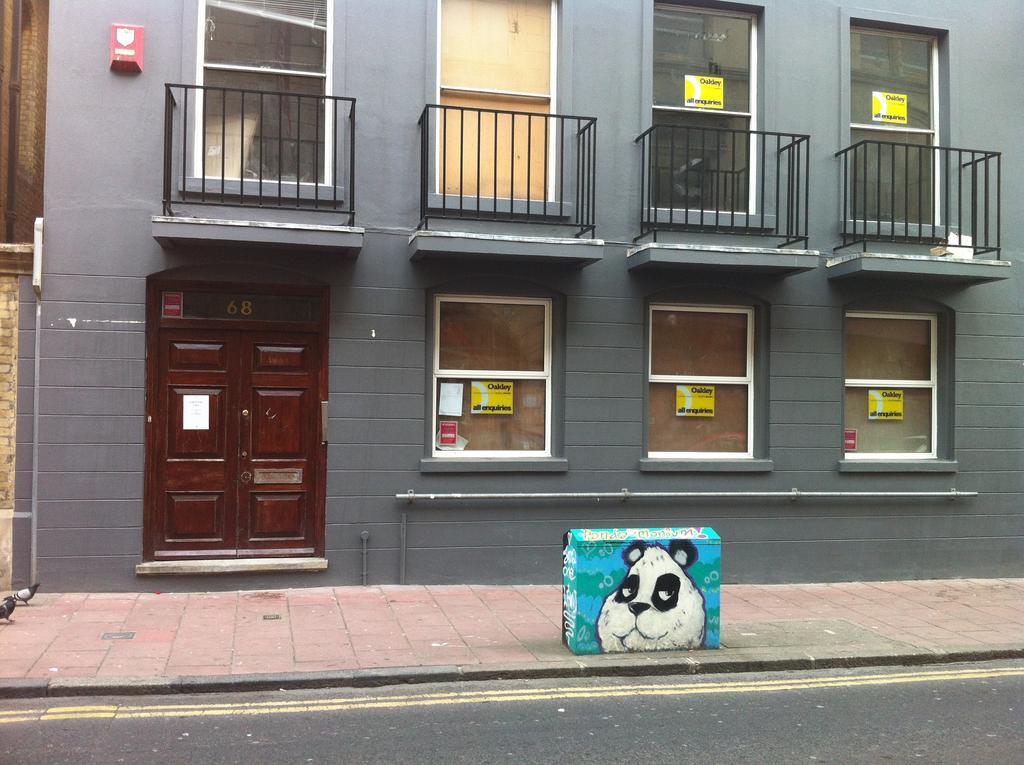Can you describe this image briefly? In this image there is a building, for that building there are doors, windows and railing, in front of the building there is footpath and a road on that footpath there is a painting on small structure. 